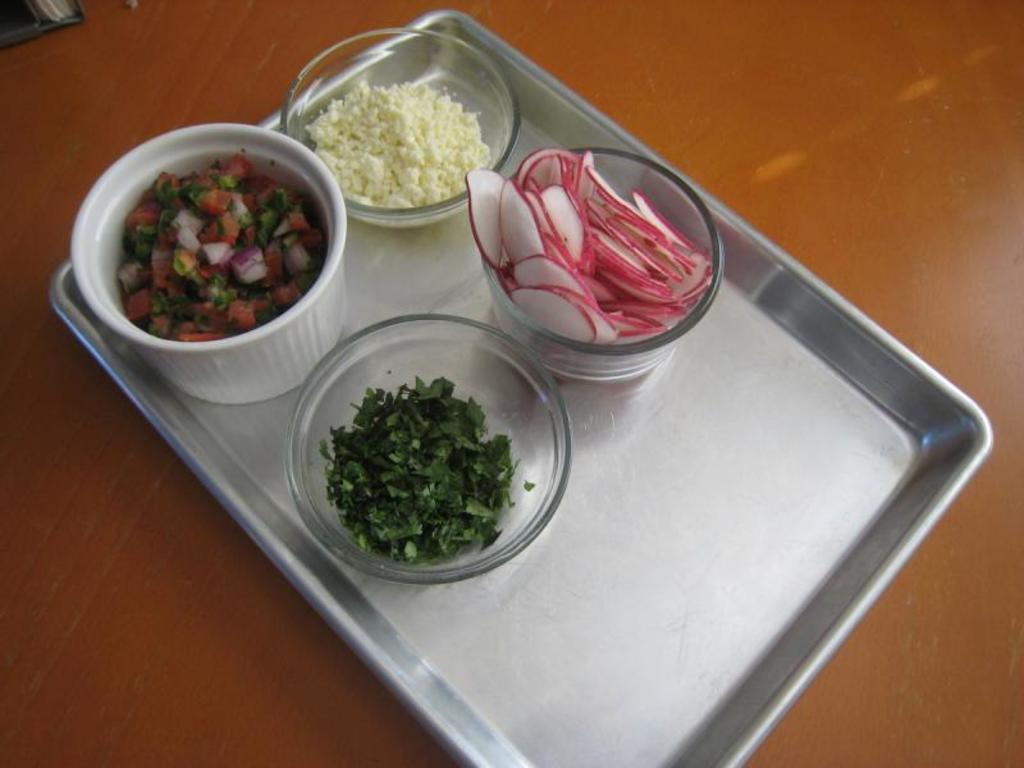What object is located in the middle of the image? There is a metal tray in the middle of the image. How many bowls are on the tray? There are four bowls on the tray. What is inside the bowls? The bowls contain food. On what surface is the tray placed? The tray is on a surface. What type of tools does the carpenter use to measure the babies in the image? There is no carpenter, tools, or babies present in the image. 